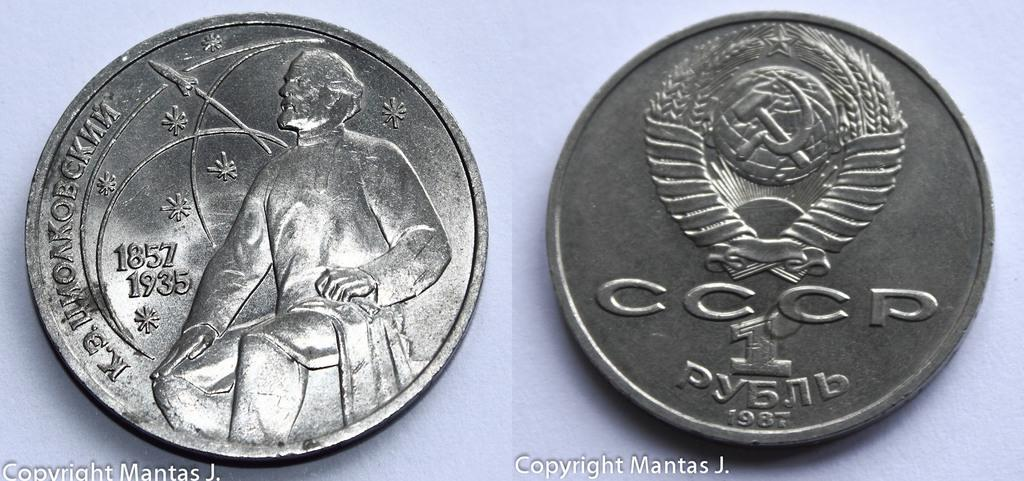<image>
Provide a brief description of the given image. Two silver coins next to each other with Copyright Mantas J. below them 